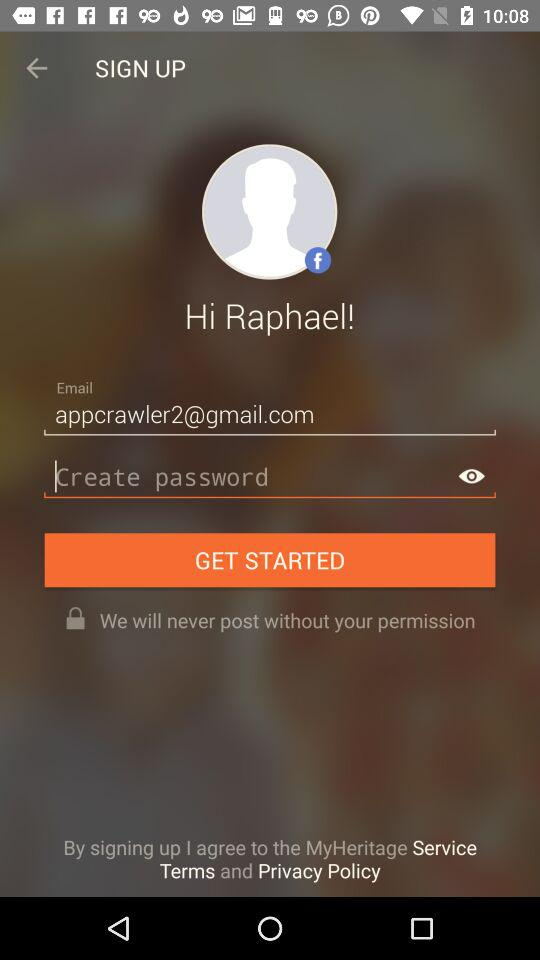What is the email address? The email address is "appcrawler2@gmail.com". 